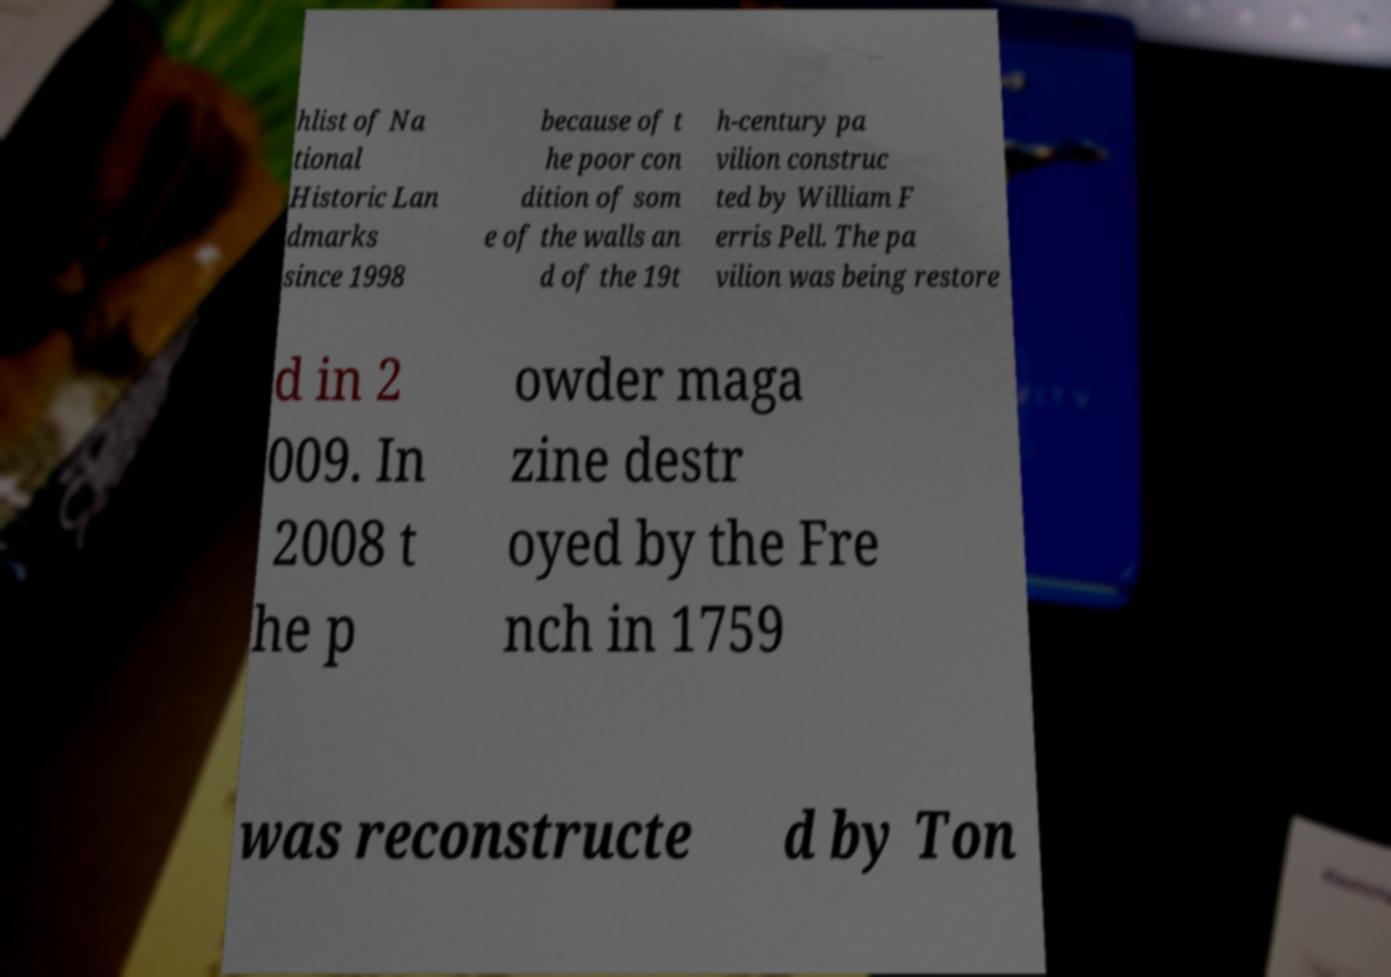Could you extract and type out the text from this image? hlist of Na tional Historic Lan dmarks since 1998 because of t he poor con dition of som e of the walls an d of the 19t h-century pa vilion construc ted by William F erris Pell. The pa vilion was being restore d in 2 009. In 2008 t he p owder maga zine destr oyed by the Fre nch in 1759 was reconstructe d by Ton 